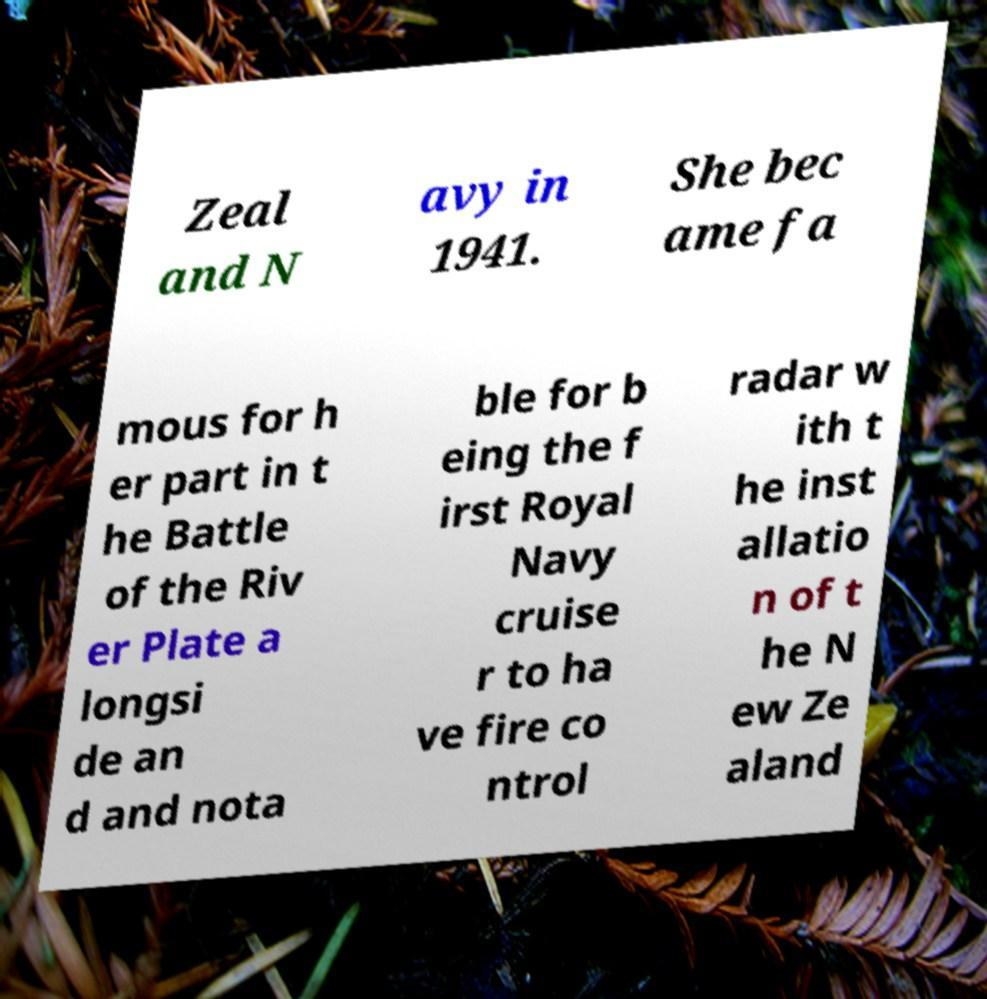Please identify and transcribe the text found in this image. Zeal and N avy in 1941. She bec ame fa mous for h er part in t he Battle of the Riv er Plate a longsi de an d and nota ble for b eing the f irst Royal Navy cruise r to ha ve fire co ntrol radar w ith t he inst allatio n of t he N ew Ze aland 